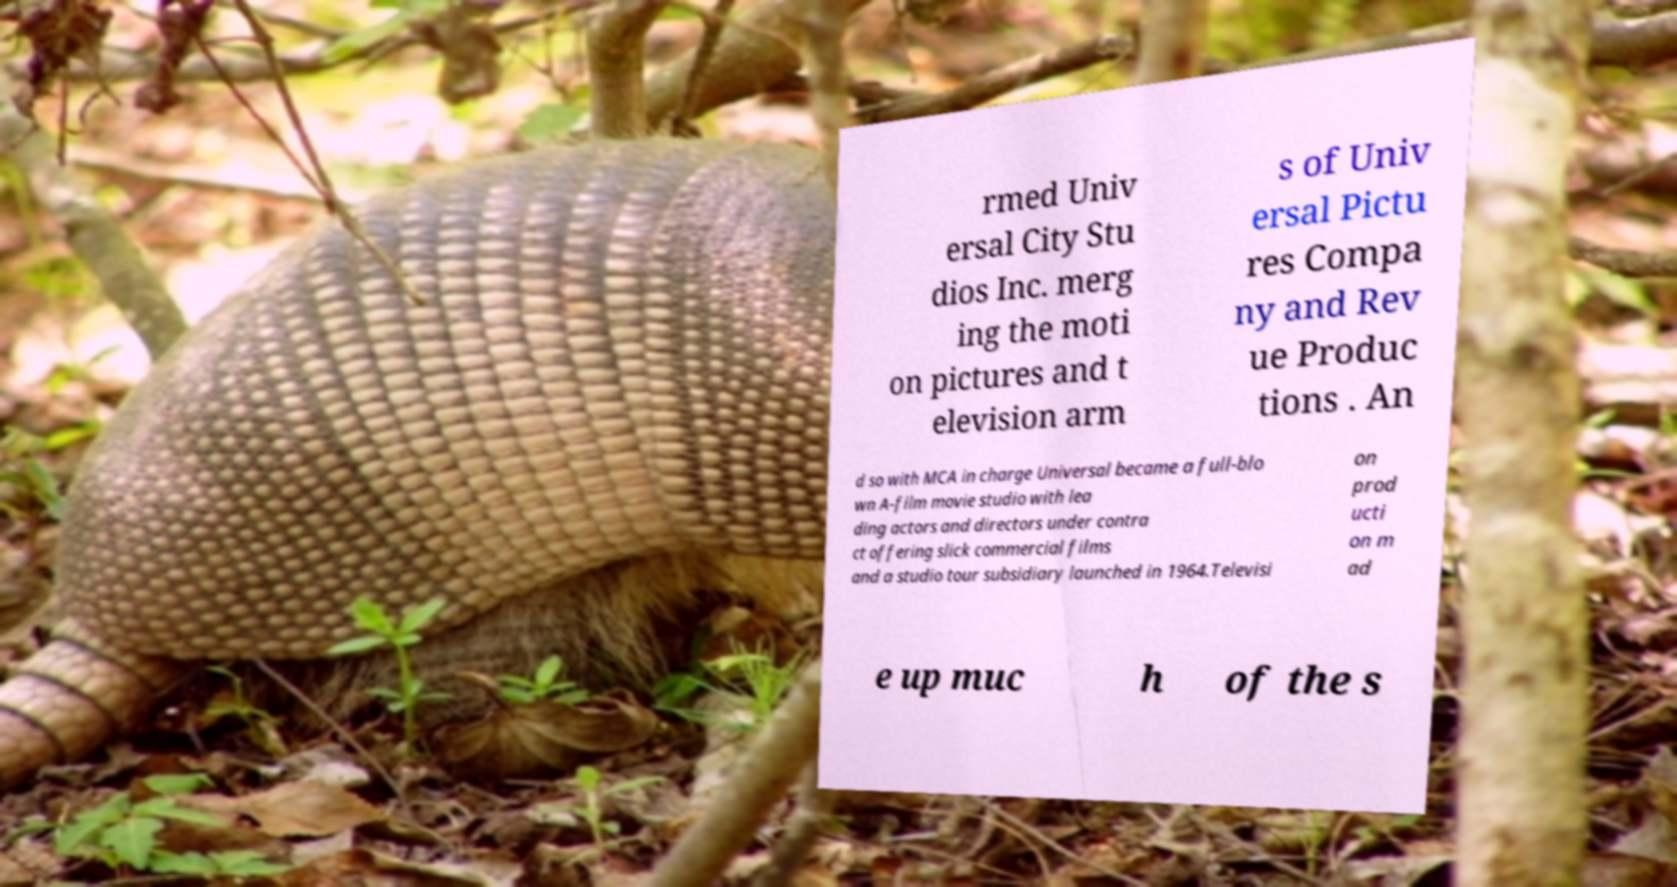Can you accurately transcribe the text from the provided image for me? rmed Univ ersal City Stu dios Inc. merg ing the moti on pictures and t elevision arm s of Univ ersal Pictu res Compa ny and Rev ue Produc tions . An d so with MCA in charge Universal became a full-blo wn A-film movie studio with lea ding actors and directors under contra ct offering slick commercial films and a studio tour subsidiary launched in 1964.Televisi on prod ucti on m ad e up muc h of the s 